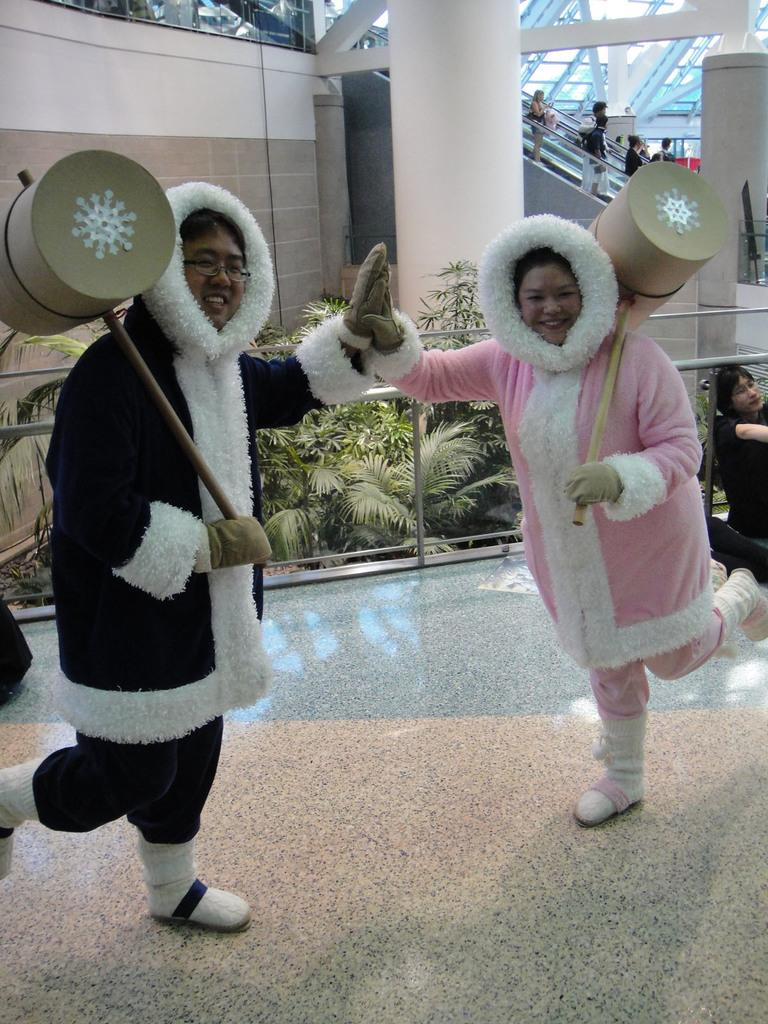How many people are in the image? There are two persons in the image. What are the persons wearing? The persons are wearing costumes. What are the persons holding in their hands? The persons are holding hammers in their hands. What can be seen in the background of the image? There is a fencing, trees, a pillar, and a wall in the background of the image. What type of wilderness can be seen in the background of the image? There is no wilderness present in the image; the background features a fencing, trees, a pillar, and a wall. How many ways are there to reach the persons in the image? The question cannot be answered definitively based on the provided facts, as there is no information about the location or accessibility of the persons in the image. 